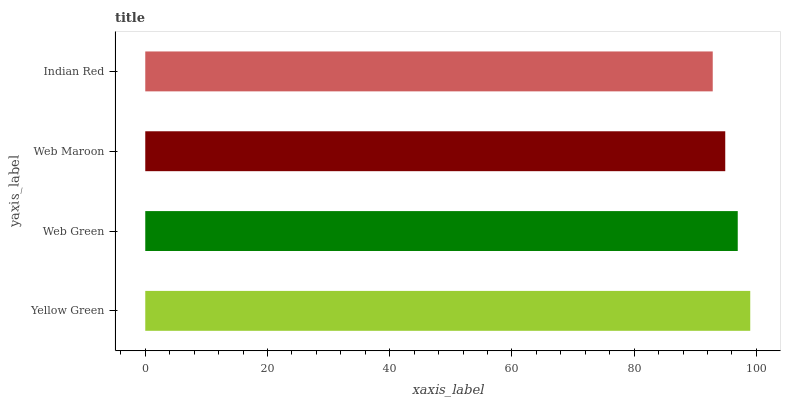Is Indian Red the minimum?
Answer yes or no. Yes. Is Yellow Green the maximum?
Answer yes or no. Yes. Is Web Green the minimum?
Answer yes or no. No. Is Web Green the maximum?
Answer yes or no. No. Is Yellow Green greater than Web Green?
Answer yes or no. Yes. Is Web Green less than Yellow Green?
Answer yes or no. Yes. Is Web Green greater than Yellow Green?
Answer yes or no. No. Is Yellow Green less than Web Green?
Answer yes or no. No. Is Web Green the high median?
Answer yes or no. Yes. Is Web Maroon the low median?
Answer yes or no. Yes. Is Yellow Green the high median?
Answer yes or no. No. Is Yellow Green the low median?
Answer yes or no. No. 